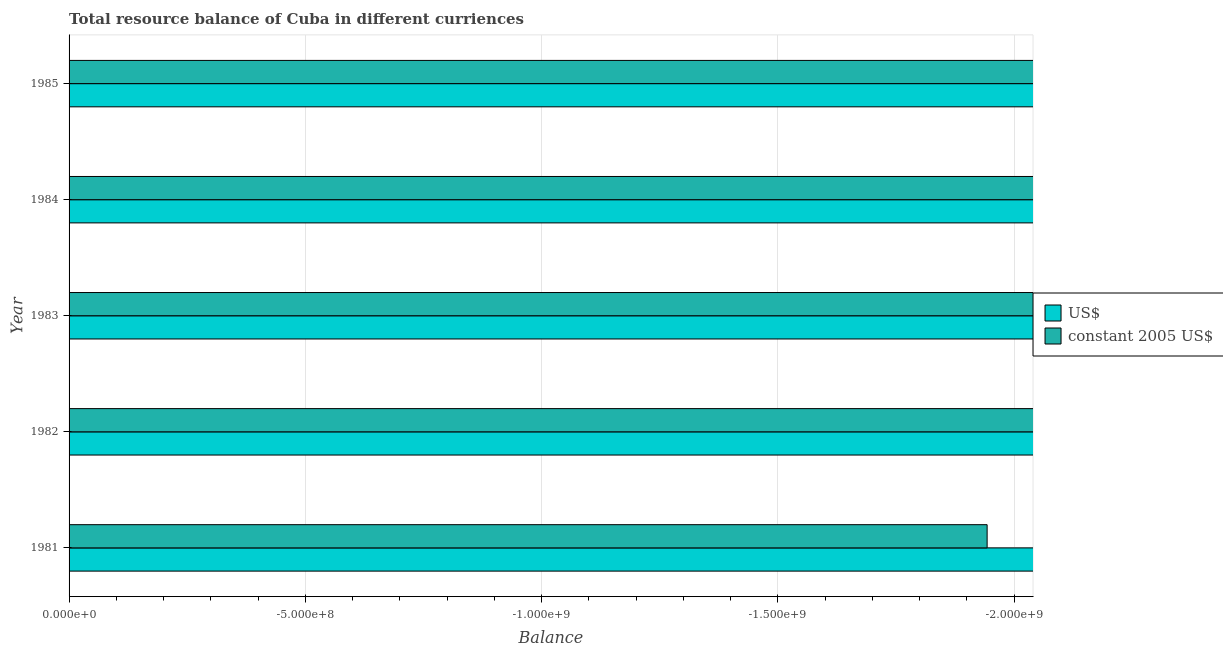How many different coloured bars are there?
Your answer should be compact. 0. What is the label of the 2nd group of bars from the top?
Offer a terse response. 1984. In how many cases, is the number of bars for a given year not equal to the number of legend labels?
Your answer should be very brief. 5. What is the difference between the resource balance in us$ in 1983 and the resource balance in constant us$ in 1982?
Your answer should be very brief. 0. What is the average resource balance in constant us$ per year?
Make the answer very short. 0. In how many years, is the resource balance in us$ greater than -600000000 units?
Keep it short and to the point. 0. In how many years, is the resource balance in us$ greater than the average resource balance in us$ taken over all years?
Provide a short and direct response. 0. How many years are there in the graph?
Make the answer very short. 5. Where does the legend appear in the graph?
Offer a terse response. Center right. How many legend labels are there?
Provide a succinct answer. 2. How are the legend labels stacked?
Make the answer very short. Vertical. What is the title of the graph?
Keep it short and to the point. Total resource balance of Cuba in different curriences. What is the label or title of the X-axis?
Offer a very short reply. Balance. What is the label or title of the Y-axis?
Give a very brief answer. Year. What is the Balance in constant 2005 US$ in 1981?
Make the answer very short. 0. What is the Balance of constant 2005 US$ in 1982?
Your answer should be very brief. 0. What is the Balance in US$ in 1983?
Your answer should be very brief. 0. What is the Balance of constant 2005 US$ in 1983?
Offer a terse response. 0. What is the Balance of US$ in 1984?
Provide a short and direct response. 0. What is the Balance of US$ in 1985?
Provide a short and direct response. 0. What is the Balance in constant 2005 US$ in 1985?
Offer a very short reply. 0. What is the total Balance in US$ in the graph?
Offer a very short reply. 0. 